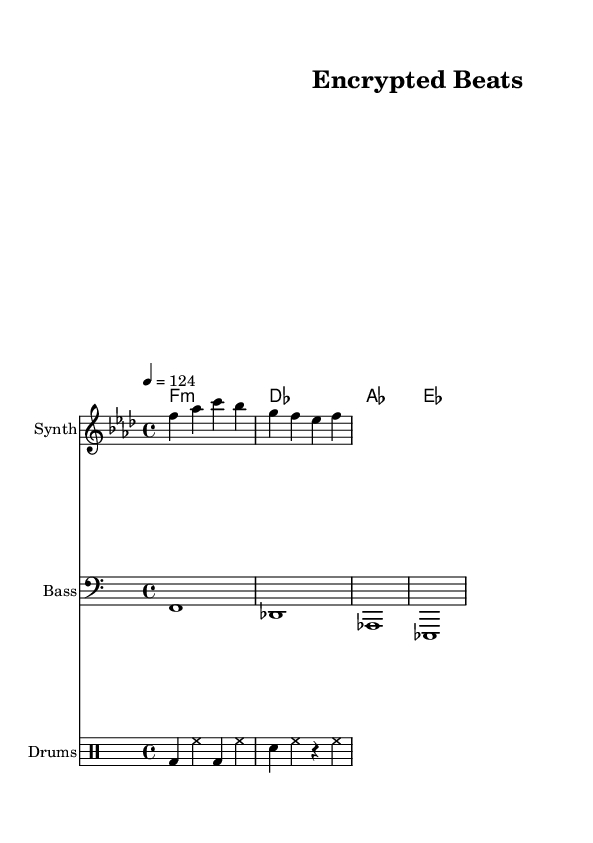What is the key signature of this music? The key signature indicated is F minor, which includes four flats: B flat, E flat, A flat, and D flat. This is deduced from the global music settings, where it specifies the `\key f \minor`.
Answer: F minor What is the time signature of this composition? The time signature shown is 4/4, which means there are four beats in a measure and the quarter note gets one beat. This is apparent in the `\time` directive within the global settings.
Answer: 4/4 What is the tempo of the piece? The tempo is set at 124 beats per minute, as indicated by `\tempo 4 = 124` in the global music settings. This means that a quarter note is played at a rate of 124 beats each minute.
Answer: 124 What is the primary theme reflected in the lyrics? The primary theme of the lyrics revolves around cybersecurity and data protection, highlighted by terms like "encryption" and "data locked tight". This aligns with the overall essence of the deep house genre focusing on contemporary themes mixed with electronic beats.
Answer: Cybersecurity What instruments are indicated for this piece? The piece features a Synth, Bass, and Drums as denoted in the `instrumentName` sections for each staff. Each instrument contributes to the overall house music style that is prevalent in this composition.
Answer: Synth, Bass, Drums What is the mood conveyed by the lyrics and music? The mood conveyed is one of security and protection, as emphasized in the lyrics with phrases like "guarding our data". Coupled with the upbeat tempo typical of house music, it creates a sense of confidence in digital safety.
Answer: Safe 